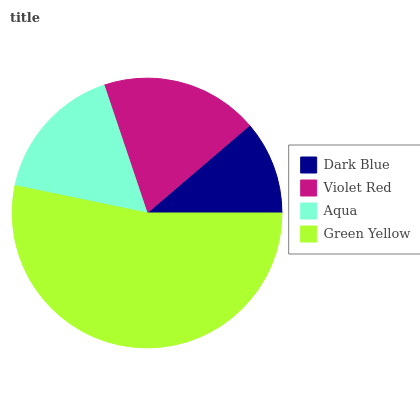Is Dark Blue the minimum?
Answer yes or no. Yes. Is Green Yellow the maximum?
Answer yes or no. Yes. Is Violet Red the minimum?
Answer yes or no. No. Is Violet Red the maximum?
Answer yes or no. No. Is Violet Red greater than Dark Blue?
Answer yes or no. Yes. Is Dark Blue less than Violet Red?
Answer yes or no. Yes. Is Dark Blue greater than Violet Red?
Answer yes or no. No. Is Violet Red less than Dark Blue?
Answer yes or no. No. Is Violet Red the high median?
Answer yes or no. Yes. Is Aqua the low median?
Answer yes or no. Yes. Is Dark Blue the high median?
Answer yes or no. No. Is Violet Red the low median?
Answer yes or no. No. 